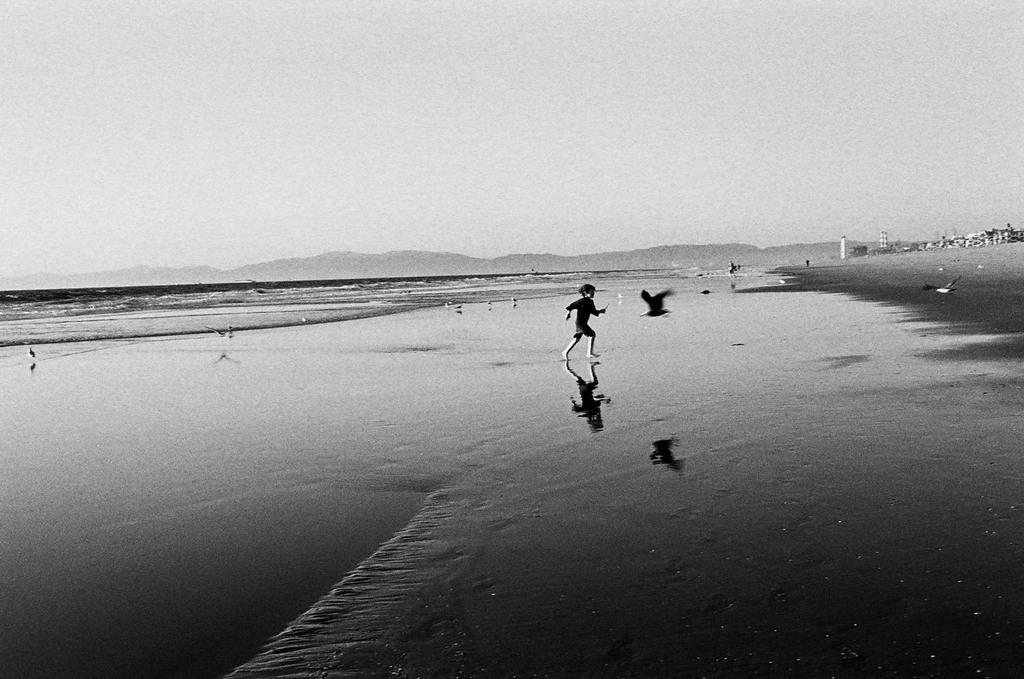What is the kid doing in the water in the image? The kid is running in the water in the image. What else is present in the image besides the kid running in the water? There is a bird flying beside the kid and buildings in the right corner of the image. What can be seen in the left corner of the image? There is water visible in the left corner of the image. What type of cable is being used by the lawyer in the alley in the image? There is no cable, lawyer, or alley present in the image. 